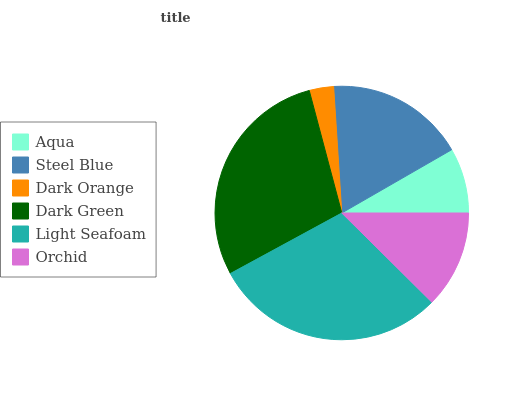Is Dark Orange the minimum?
Answer yes or no. Yes. Is Light Seafoam the maximum?
Answer yes or no. Yes. Is Steel Blue the minimum?
Answer yes or no. No. Is Steel Blue the maximum?
Answer yes or no. No. Is Steel Blue greater than Aqua?
Answer yes or no. Yes. Is Aqua less than Steel Blue?
Answer yes or no. Yes. Is Aqua greater than Steel Blue?
Answer yes or no. No. Is Steel Blue less than Aqua?
Answer yes or no. No. Is Steel Blue the high median?
Answer yes or no. Yes. Is Orchid the low median?
Answer yes or no. Yes. Is Dark Green the high median?
Answer yes or no. No. Is Aqua the low median?
Answer yes or no. No. 